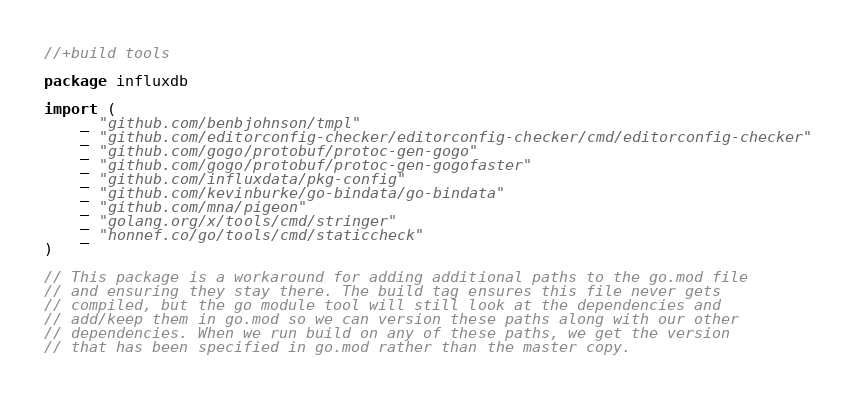Convert code to text. <code><loc_0><loc_0><loc_500><loc_500><_Go_>//+build tools

package influxdb

import (
	_ "github.com/benbjohnson/tmpl"
	_ "github.com/editorconfig-checker/editorconfig-checker/cmd/editorconfig-checker"
	_ "github.com/gogo/protobuf/protoc-gen-gogo"
	_ "github.com/gogo/protobuf/protoc-gen-gogofaster"
	_ "github.com/influxdata/pkg-config"
	_ "github.com/kevinburke/go-bindata/go-bindata"
	_ "github.com/mna/pigeon"
	_ "golang.org/x/tools/cmd/stringer"
	_ "honnef.co/go/tools/cmd/staticcheck"
)

// This package is a workaround for adding additional paths to the go.mod file
// and ensuring they stay there. The build tag ensures this file never gets
// compiled, but the go module tool will still look at the dependencies and
// add/keep them in go.mod so we can version these paths along with our other
// dependencies. When we run build on any of these paths, we get the version
// that has been specified in go.mod rather than the master copy.
</code> 